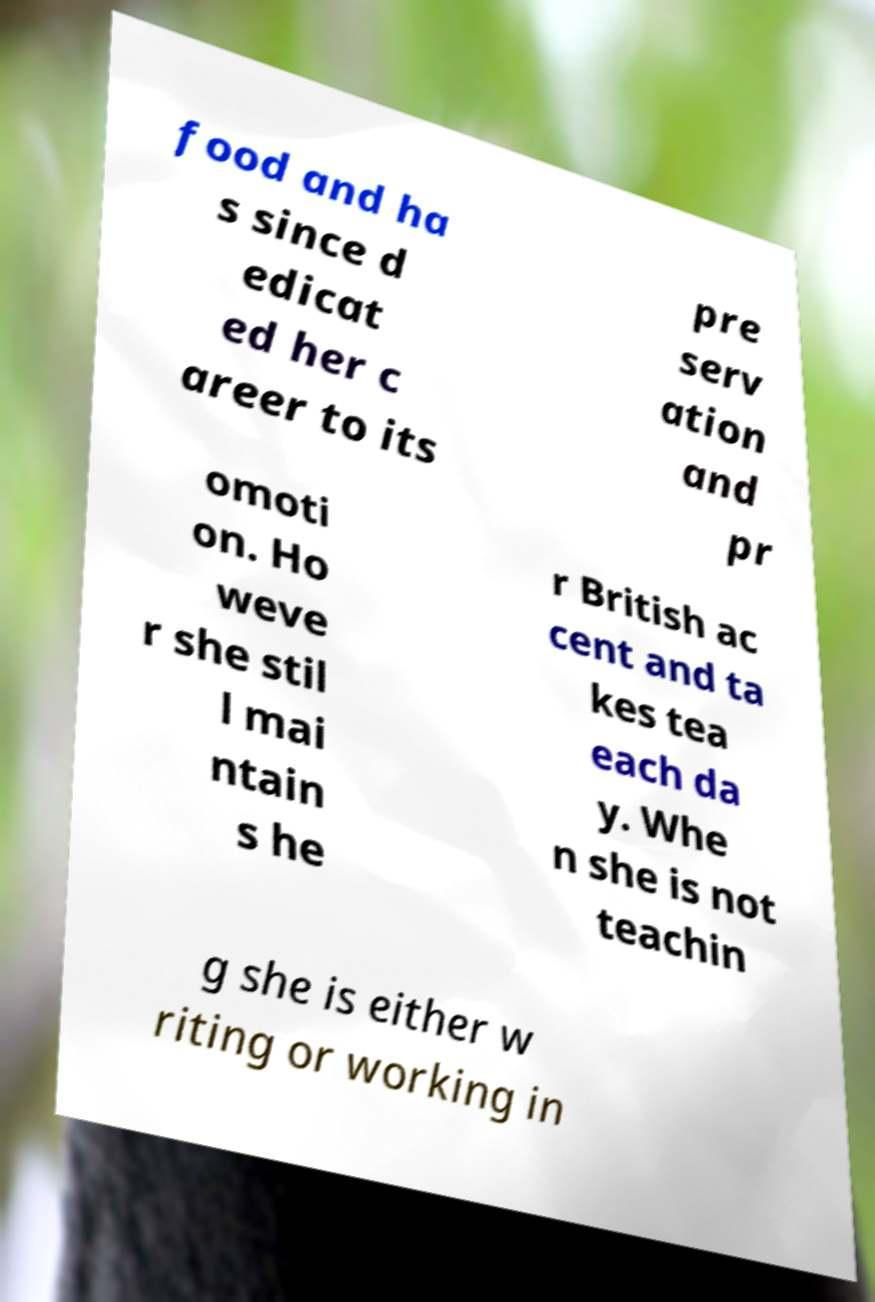Could you assist in decoding the text presented in this image and type it out clearly? food and ha s since d edicat ed her c areer to its pre serv ation and pr omoti on. Ho weve r she stil l mai ntain s he r British ac cent and ta kes tea each da y. Whe n she is not teachin g she is either w riting or working in 